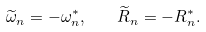<formula> <loc_0><loc_0><loc_500><loc_500>\widetilde { \omega } _ { n } = - \omega _ { n } ^ { * } , \quad \widetilde { R } _ { n } = - R _ { n } ^ { * } .</formula> 